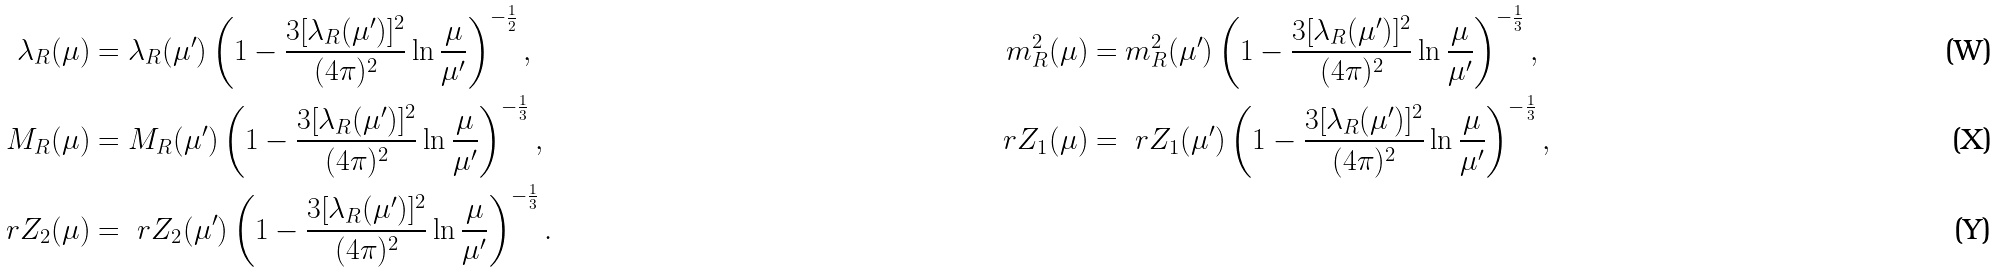Convert formula to latex. <formula><loc_0><loc_0><loc_500><loc_500>\lambda _ { R } ( \mu ) & = \lambda _ { R } ( \mu ^ { \prime } ) \left ( 1 - \frac { 3 [ \lambda _ { R } ( \mu ^ { \prime } ) ] ^ { 2 } } { ( 4 \pi ) ^ { 2 } } \ln \frac { \mu } { \mu ^ { \prime } } \right ) ^ { - \frac { 1 } { 2 } } , & m ^ { 2 } _ { R } ( \mu ) & = m _ { R } ^ { 2 } ( \mu ^ { \prime } ) \left ( 1 - \frac { 3 [ \lambda _ { R } ( \mu ^ { \prime } ) ] ^ { 2 } } { ( 4 \pi ) ^ { 2 } } \ln \frac { \mu } { \mu ^ { \prime } } \right ) ^ { - \frac { 1 } { 3 } } , \\ M _ { R } ( \mu ) & = M _ { R } ( \mu ^ { \prime } ) \left ( 1 - \frac { 3 [ \lambda _ { R } ( \mu ^ { \prime } ) ] ^ { 2 } } { ( 4 \pi ) ^ { 2 } } \ln \frac { \mu } { \mu ^ { \prime } } \right ) ^ { - \frac { 1 } { 3 } } , & \ r Z _ { 1 } ( \mu ) & = \ r Z _ { 1 } ( \mu ^ { \prime } ) \left ( 1 - \frac { 3 [ \lambda _ { R } ( \mu ^ { \prime } ) ] ^ { 2 } } { ( 4 \pi ) ^ { 2 } } \ln \frac { \mu } { \mu ^ { \prime } } \right ) ^ { - \frac { 1 } { 3 } } , \\ \ r Z _ { 2 } ( \mu ) & = \ r Z _ { 2 } ( \mu ^ { \prime } ) \left ( 1 - \frac { 3 [ \lambda _ { R } ( \mu ^ { \prime } ) ] ^ { 2 } } { ( 4 \pi ) ^ { 2 } } \ln \frac { \mu } { \mu ^ { \prime } } \right ) ^ { - \frac { 1 } { 3 } } .</formula> 